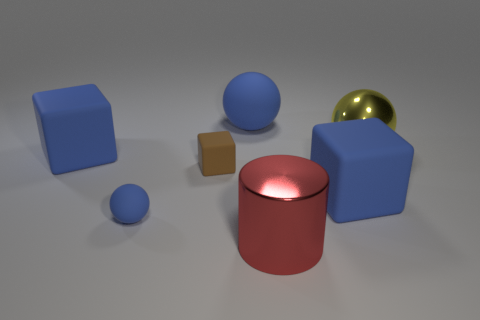Subtract all gray blocks. Subtract all green cylinders. How many blocks are left? 3 Subtract all brown spheres. How many blue cubes are left? 2 Add 3 purples. How many large reds exist? 0 Subtract all tiny purple matte spheres. Subtract all cylinders. How many objects are left? 6 Add 2 brown rubber blocks. How many brown rubber blocks are left? 3 Add 4 big yellow balls. How many big yellow balls exist? 5 Add 1 big red metallic cylinders. How many objects exist? 8 Subtract all blue spheres. How many spheres are left? 1 Subtract all blue matte cubes. How many cubes are left? 1 Subtract 1 red cylinders. How many objects are left? 6 